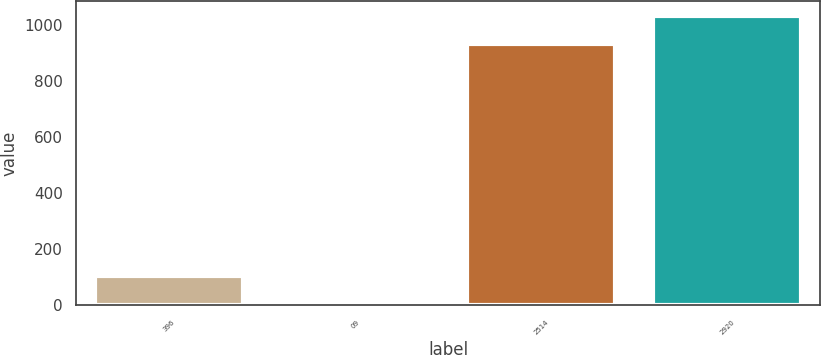Convert chart to OTSL. <chart><loc_0><loc_0><loc_500><loc_500><bar_chart><fcel>396<fcel>09<fcel>2514<fcel>2920<nl><fcel>105.39<fcel>6<fcel>933<fcel>1032.39<nl></chart> 